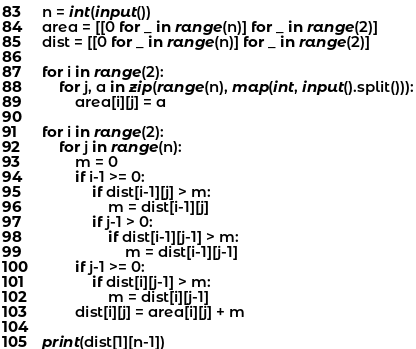Convert code to text. <code><loc_0><loc_0><loc_500><loc_500><_Python_>n = int(input())
area = [[0 for _ in range(n)] for _ in range(2)]
dist = [[0 for _ in range(n)] for _ in range(2)]

for i in range(2):
    for j, a in zip(range(n), map(int, input().split())):
        area[i][j] = a

for i in range(2):
    for j in range(n):
        m = 0
        if i-1 >= 0:
            if dist[i-1][j] > m:
                m = dist[i-1][j]
            if j-1 > 0:
                if dist[i-1][j-1] > m:
                    m = dist[i-1][j-1]
        if j-1 >= 0:
            if dist[i][j-1] > m:
                m = dist[i][j-1]
        dist[i][j] = area[i][j] + m

print(dist[1][n-1])</code> 